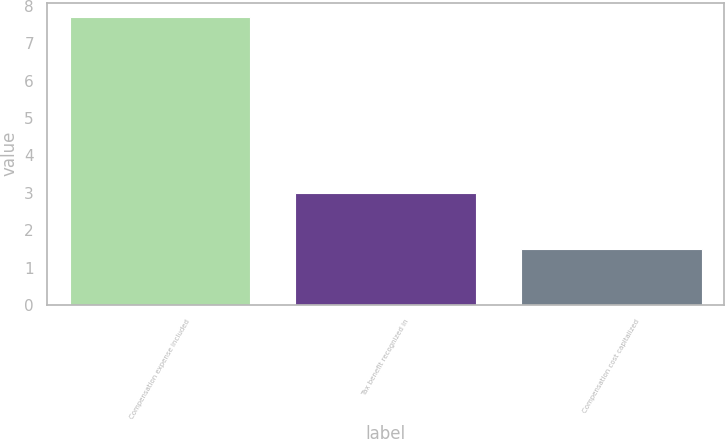Convert chart. <chart><loc_0><loc_0><loc_500><loc_500><bar_chart><fcel>Compensation expense included<fcel>Tax benefit recognized in<fcel>Compensation cost capitalized<nl><fcel>7.7<fcel>3<fcel>1.5<nl></chart> 